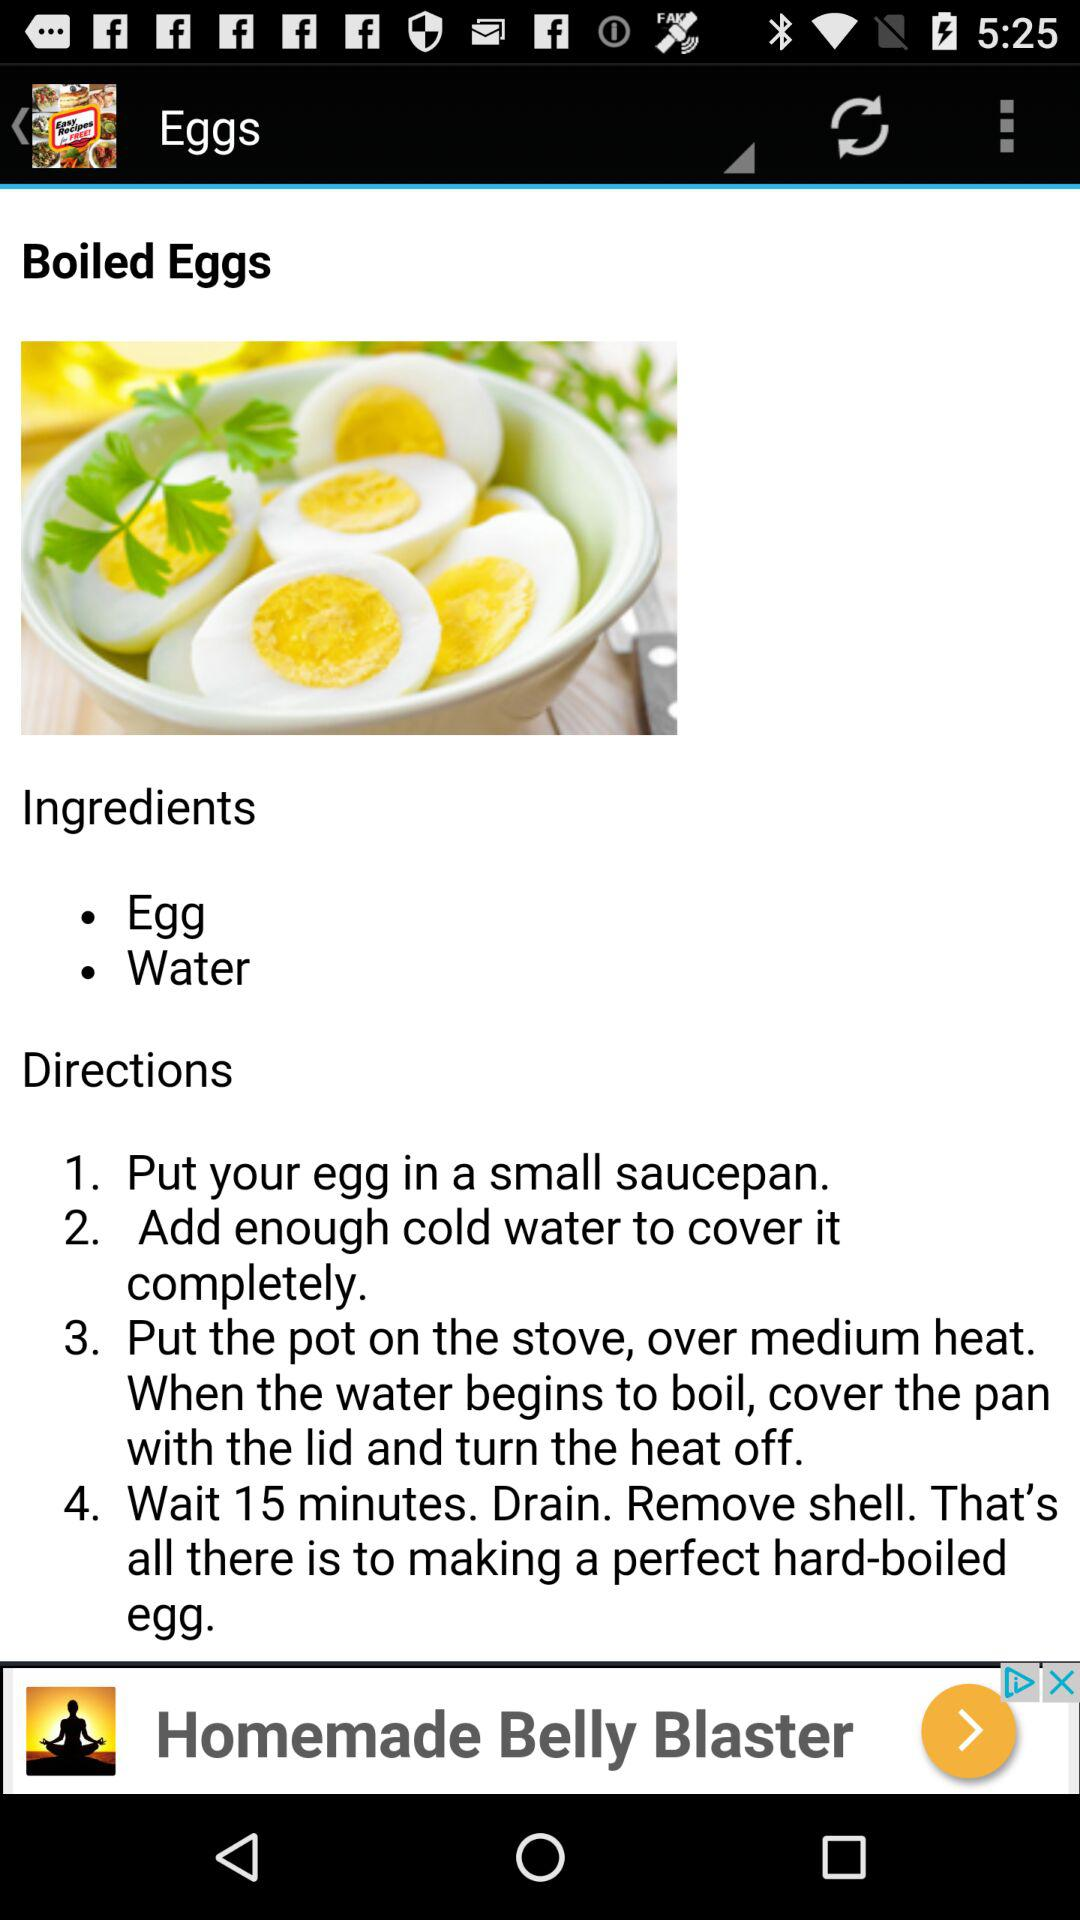How many steps are in the recipe?
Answer the question using a single word or phrase. 4 